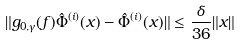<formula> <loc_0><loc_0><loc_500><loc_500>\| g _ { 0 , \gamma } ( f ) \hat { \Phi } ^ { ( i ) } ( x ) - \hat { \Phi } ^ { ( i ) } ( x ) \| \leq \frac { \delta } { 3 6 } \| x \|</formula> 